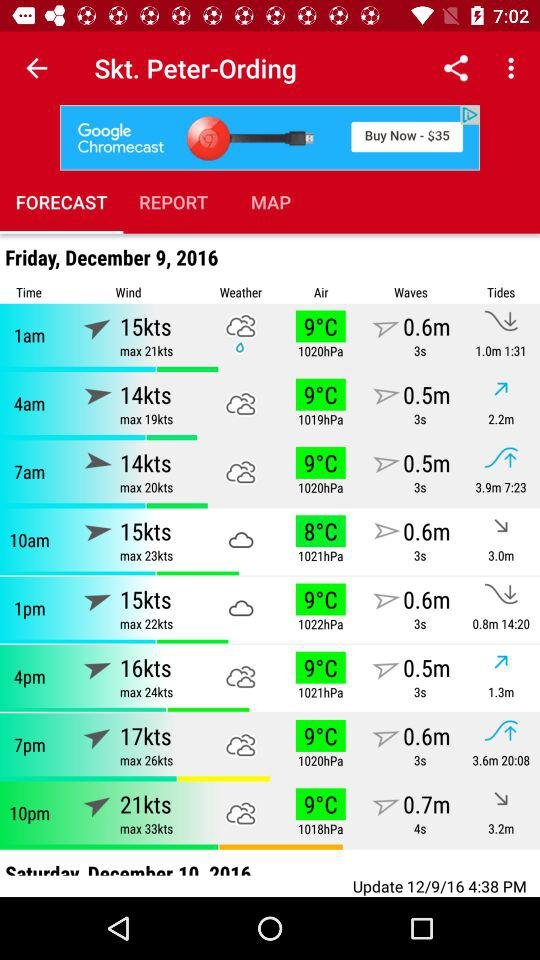How's the weather forecast for Friday, December 9, 2016 at 1 a.m.? The weather forecast for Friday, December 9, 2016 at 1 a.m. is drizzle. 